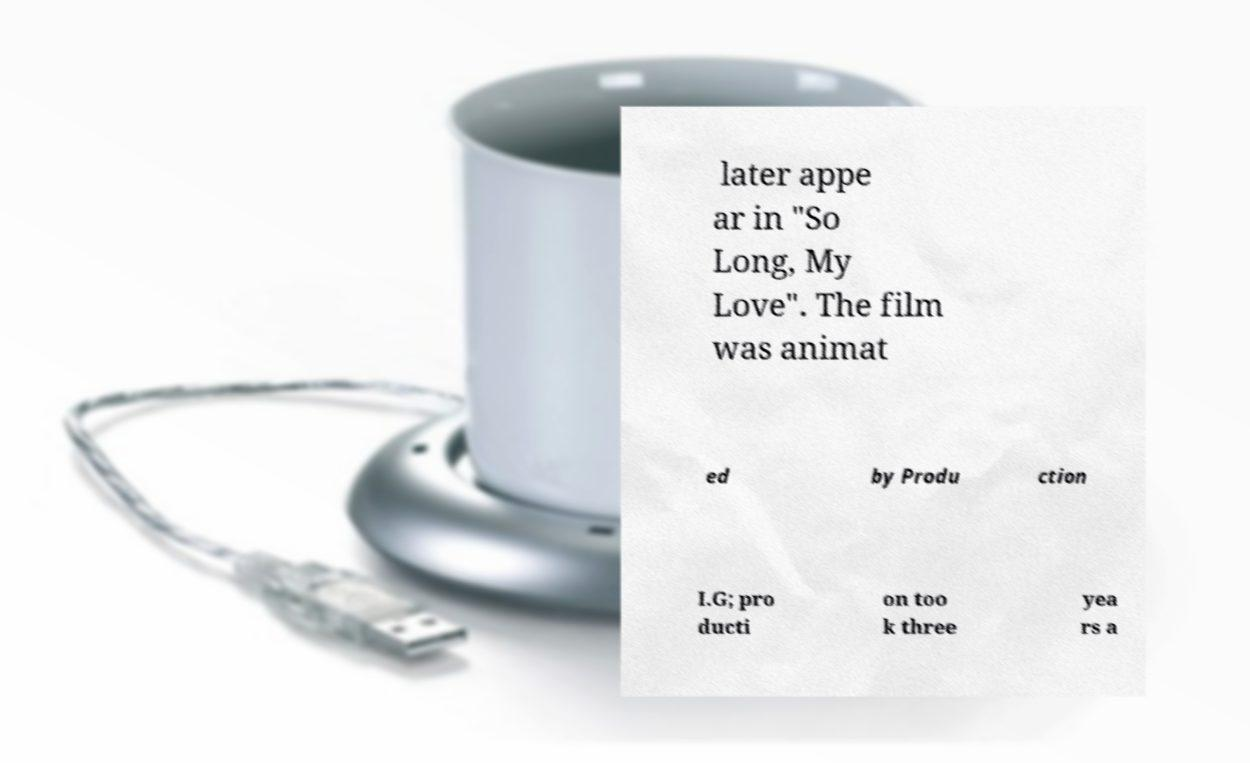For documentation purposes, I need the text within this image transcribed. Could you provide that? later appe ar in "So Long, My Love". The film was animat ed by Produ ction I.G; pro ducti on too k three yea rs a 